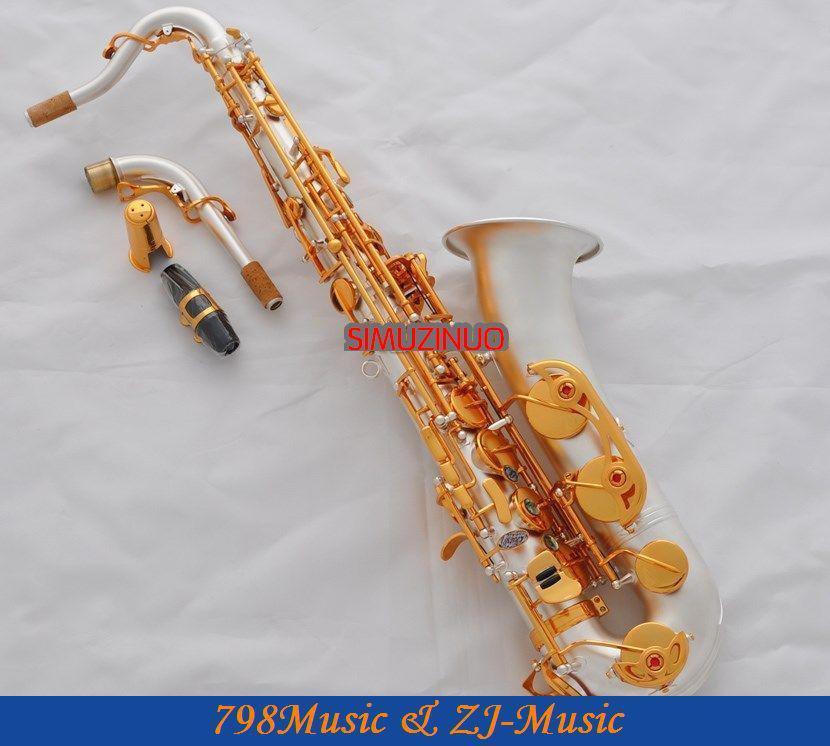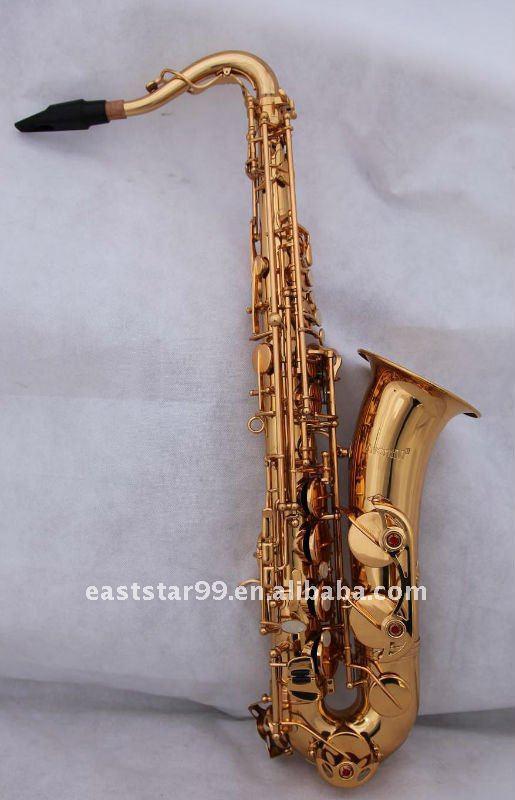The first image is the image on the left, the second image is the image on the right. For the images shown, is this caption "The left-hand instrument is vertical with a silver body." true? Answer yes or no. No. 